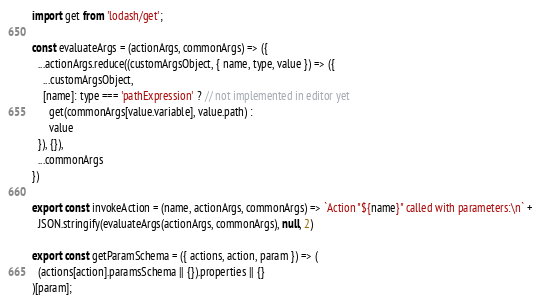Convert code to text. <code><loc_0><loc_0><loc_500><loc_500><_JavaScript_>import get from 'lodash/get';

const evaluateArgs = (actionArgs, commonArgs) => ({
  ...actionArgs.reduce((customArgsObject, { name, type, value }) => ({
    ...customArgsObject,
    [name]: type === 'pathExpression' ? // not implemented in editor yet
      get(commonArgs[value.variable], value.path) :
      value
  }), {}),
  ...commonArgs
})

export const invokeAction = (name, actionArgs, commonArgs) => `Action "${name}" called with parameters:\n` +
  JSON.stringify(evaluateArgs(actionArgs, commonArgs), null, 2)

export const getParamSchema = ({ actions, action, param }) => (
  (actions[action].paramsSchema || {}).properties || {}
)[param];
</code> 